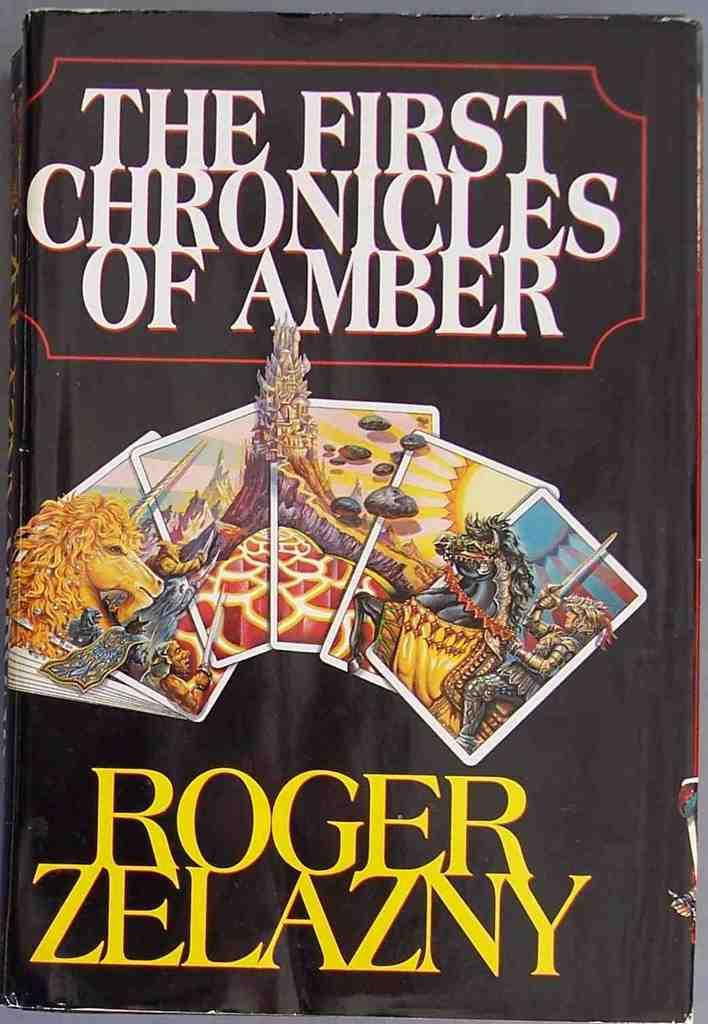<image>
Offer a succinct explanation of the picture presented. The book "The First Chronicles of Amber" by Roger Zelazny. 